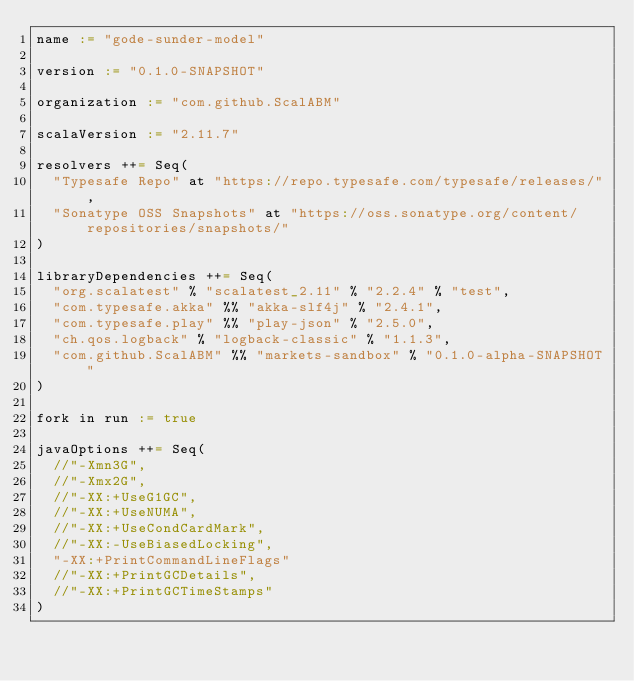<code> <loc_0><loc_0><loc_500><loc_500><_Scala_>name := "gode-sunder-model"

version := "0.1.0-SNAPSHOT"

organization := "com.github.ScalABM"

scalaVersion := "2.11.7"

resolvers ++= Seq(
  "Typesafe Repo" at "https://repo.typesafe.com/typesafe/releases/",
  "Sonatype OSS Snapshots" at "https://oss.sonatype.org/content/repositories/snapshots/"
)

libraryDependencies ++= Seq(
  "org.scalatest" % "scalatest_2.11" % "2.2.4" % "test",
  "com.typesafe.akka" %% "akka-slf4j" % "2.4.1",
  "com.typesafe.play" %% "play-json" % "2.5.0",
  "ch.qos.logback" % "logback-classic" % "1.1.3",
  "com.github.ScalABM" %% "markets-sandbox" % "0.1.0-alpha-SNAPSHOT"
)

fork in run := true

javaOptions ++= Seq(
  //"-Xmn3G",
  //"-Xmx2G",
  //"-XX:+UseG1GC",
  //"-XX:+UseNUMA",
  //"-XX:+UseCondCardMark",
  //"-XX:-UseBiasedLocking",
  "-XX:+PrintCommandLineFlags"
  //"-XX:+PrintGCDetails",
  //"-XX:+PrintGCTimeStamps"
)
</code> 